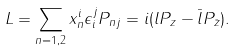<formula> <loc_0><loc_0><loc_500><loc_500>L = \sum _ { n = 1 , 2 } x ^ { i } _ { n } \epsilon _ { i } ^ { j } P _ { n j } = i ( l P _ { z } - \bar { l } P _ { \bar { z } } ) .</formula> 